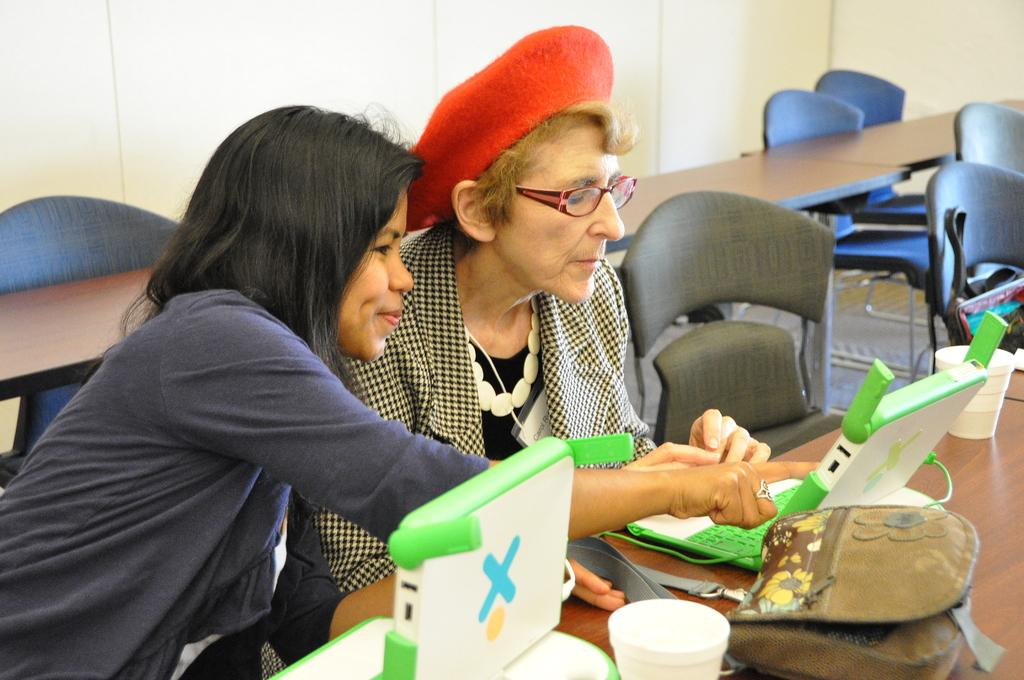How many women are sitting in the image? There are two women sitting in the image. What objects are in front of the women? There are laptops, cups, and bags in front of the women. What can be found on the table in the image? There are objects on the table. What type of furniture is present in the image? There are chairs and tables in the image. What is visible in the background of the image? There is a wall in the background of the image. What type of ticket is visible in the image? There is no ticket present in the image. What type of whip is being used by one of the women in the image? There is no whip present in the image, and neither woman is using one. 